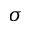Convert formula to latex. <formula><loc_0><loc_0><loc_500><loc_500>\sigma</formula> 